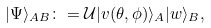<formula> <loc_0><loc_0><loc_500><loc_500>| \Psi \rangle _ { A B } \colon = \mathcal { U } | v ( \theta , \phi ) \rangle _ { A } | w \rangle _ { B } ,</formula> 